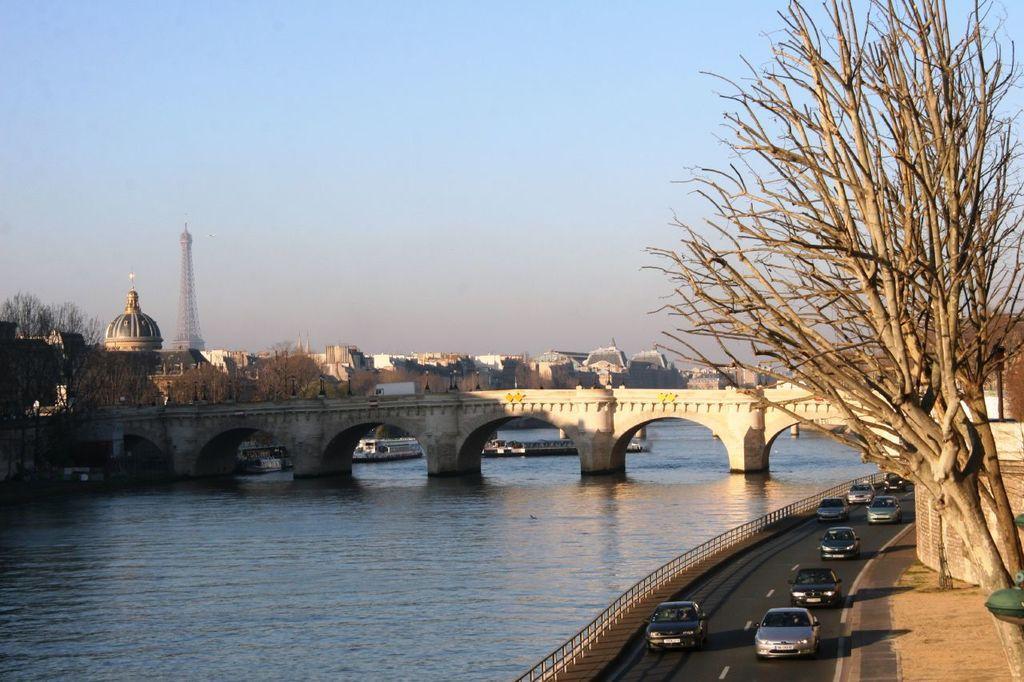Can you describe this image briefly? This image is clicked on the road. At the bottom, there is a road, on which there are many cars moving. On the right, there is a tree. On the left, we can see a bridge along with water. In the background, there are many houses and a tower. At the top, there is a sky. 